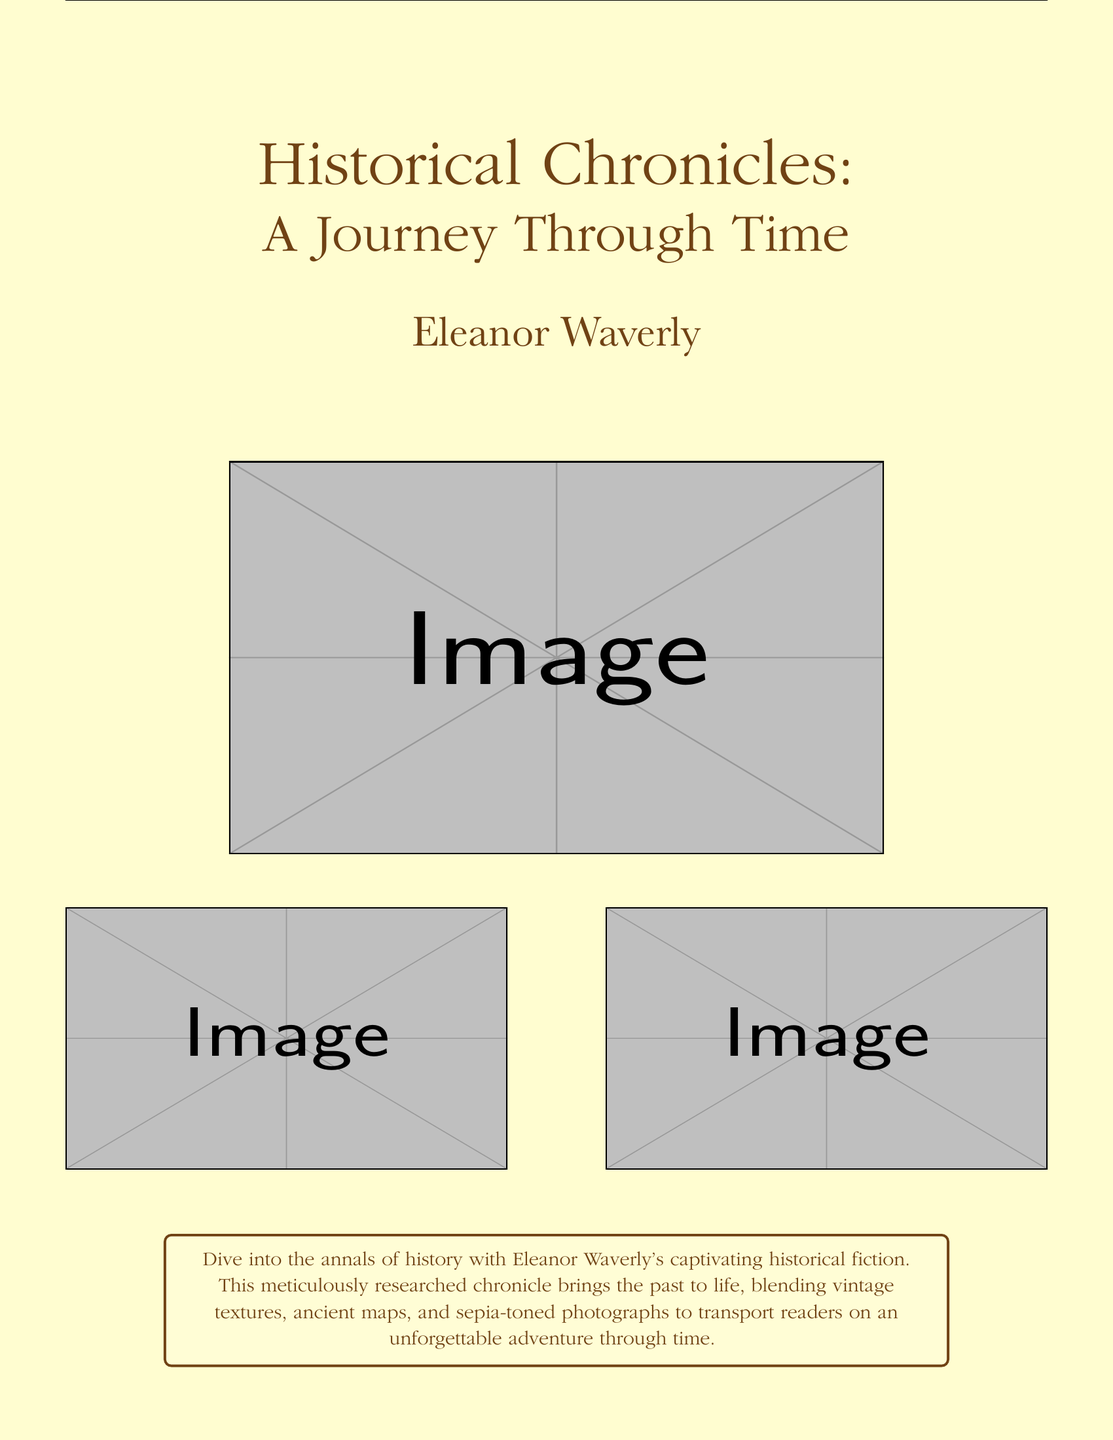What is the title of the book? The title of the book is prominently displayed in large type on the cover.
Answer: Historical Chronicles Who is the author of the book? The author's name is located beneath the title in a distinct font.
Answer: Eleanor Waverly What type of literature does this book represent? The genre of the book is mentioned in the description section.
Answer: Historical fiction What key visual elements are used in the book cover design? The cover features elements like vintage textures, ancient maps, and sepia-toned photographs.
Answer: Vintage textures, ancient maps, sepia-toned photographs What is the purpose of the tcolorbox on the cover? The tcolorbox provides a summary that highlights the book's theme and purpose.
Answer: To summarize the book's theme How many images are used on the cover? The cover has three images displayed in total—one large and two smaller ones.
Answer: Three images What color is the text associated with the title? The color used for the title's text is specified in the document.
Answer: Sepia What does the description suggest about the author's research? The description refers to the research quality of the author's work.
Answer: Meticulously researched What kind of adventure does the book promise to readers? The description indicates the nature of the adventure offered in the book.
Answer: Unforgettable adventure through time 